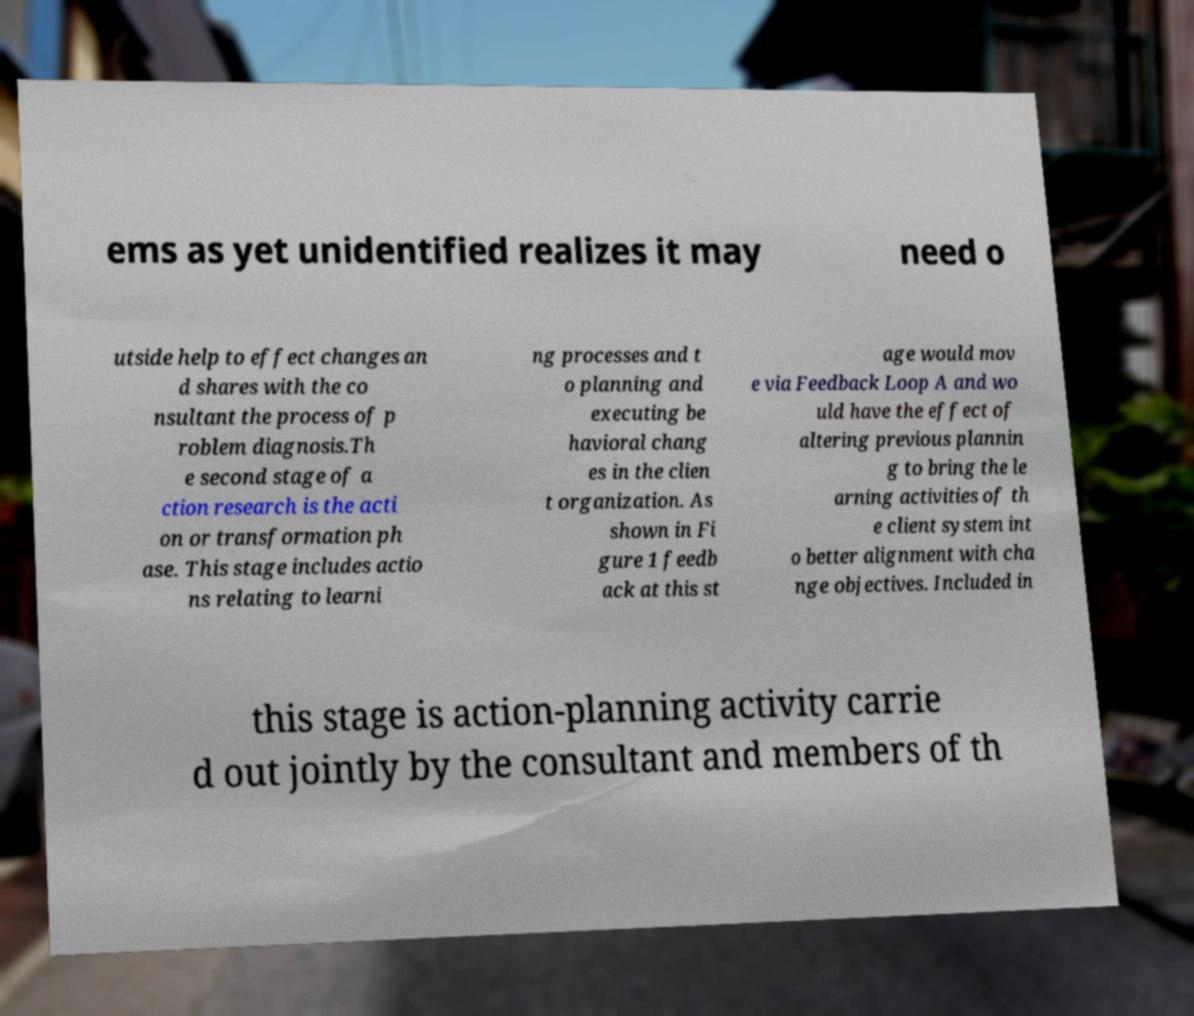There's text embedded in this image that I need extracted. Can you transcribe it verbatim? ems as yet unidentified realizes it may need o utside help to effect changes an d shares with the co nsultant the process of p roblem diagnosis.Th e second stage of a ction research is the acti on or transformation ph ase. This stage includes actio ns relating to learni ng processes and t o planning and executing be havioral chang es in the clien t organization. As shown in Fi gure 1 feedb ack at this st age would mov e via Feedback Loop A and wo uld have the effect of altering previous plannin g to bring the le arning activities of th e client system int o better alignment with cha nge objectives. Included in this stage is action-planning activity carrie d out jointly by the consultant and members of th 